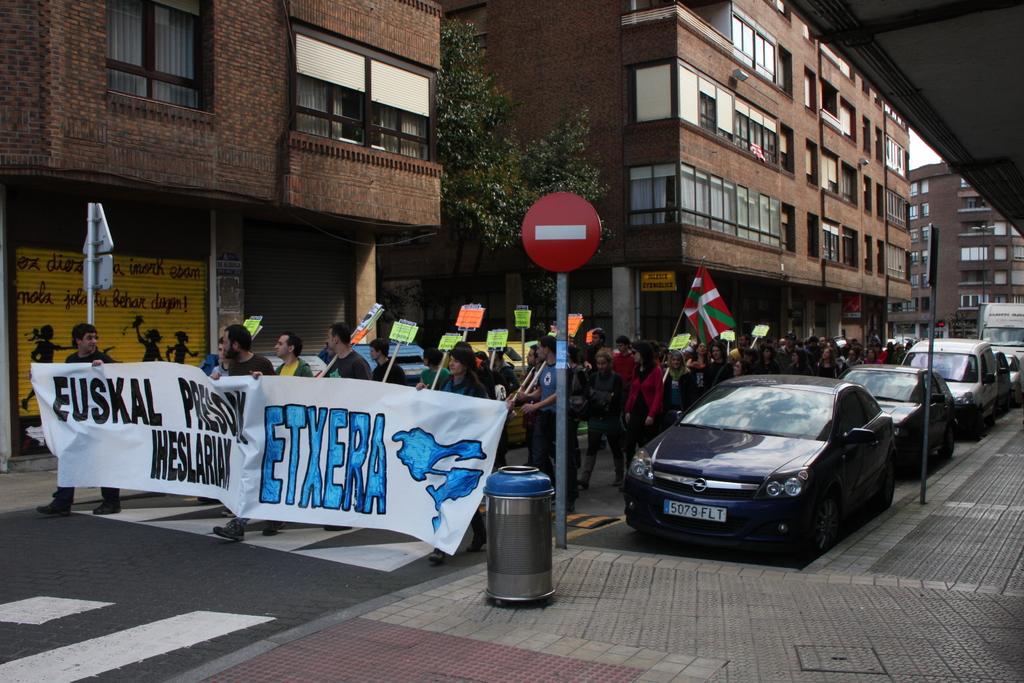Can you describe this image briefly? This picture shows few buildings, trees and we see cars parked on the side of the road and we see sign boards on the sidewalk and a dustbin and we see people walking holding placards in their hands and a flag and few of them holding a banner and we see a truck parked on the last. 